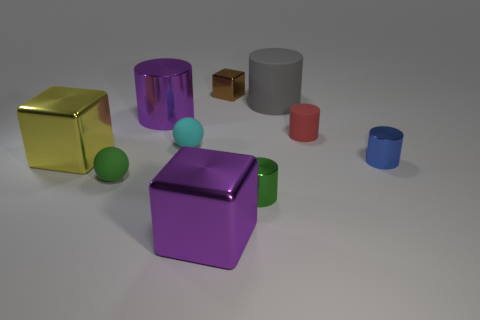Subtract 1 cylinders. How many cylinders are left? 4 Subtract all big purple metal cylinders. How many cylinders are left? 4 Subtract all red cylinders. How many cylinders are left? 4 Subtract all cyan cylinders. Subtract all gray balls. How many cylinders are left? 5 Subtract all cubes. How many objects are left? 7 Add 6 big yellow metal cubes. How many big yellow metal cubes exist? 7 Subtract 0 brown cylinders. How many objects are left? 10 Subtract all metallic cubes. Subtract all balls. How many objects are left? 5 Add 8 small metal cubes. How many small metal cubes are left? 9 